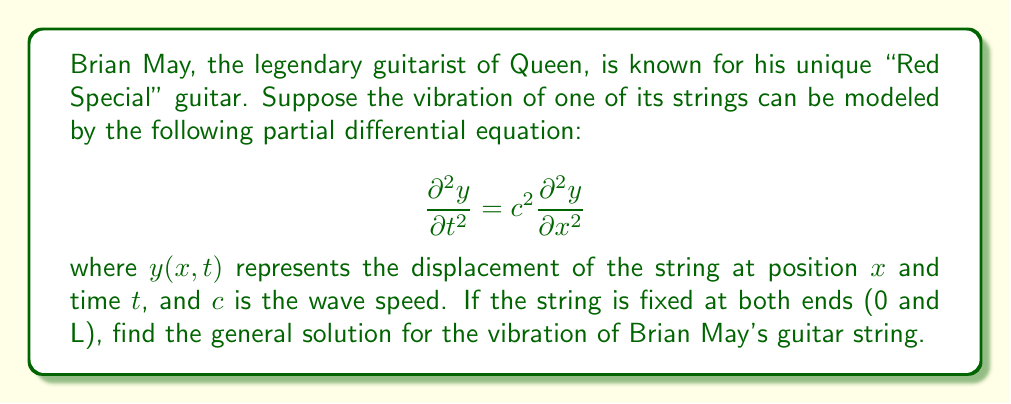Help me with this question. To solve this partial differential equation (PDE) for Brian May's guitar string, we'll follow these steps:

1) First, we need to recognize this as the one-dimensional wave equation. The boundary conditions for a string fixed at both ends are:

   $y(0,t) = y(L,t) = 0$ for all $t$

2) We'll use the method of separation of variables. Let $y(x,t) = X(x)T(t)$

3) Substituting this into the PDE:

   $X(x)T''(t) = c^2X''(x)T(t)$

4) Dividing both sides by $c^2X(x)T(t)$:

   $\frac{T''(t)}{c^2T(t)} = \frac{X''(x)}{X(x)} = -k^2$

   where $-k^2$ is a separation constant (negative to ensure oscillatory solutions).

5) This gives us two ordinary differential equations:

   $T''(t) + c^2k^2T(t) = 0$
   $X''(x) + k^2X(x) = 0$

6) The general solutions are:

   $T(t) = A \cos(ckt) + B \sin(ckt)$
   $X(x) = C \sin(kx) + D \cos(kx)$

7) Applying the boundary conditions:

   $X(0) = 0$ implies $D = 0$
   $X(L) = 0$ implies $\sin(kL) = 0$

8) The latter condition is satisfied when $kL = n\pi$, or $k = \frac{n\pi}{L}$ where $n = 1, 2, 3, ...$

9) Therefore, the general solution is:

   $y_n(x,t) = [A_n \cos(\frac{cn\pi t}{L}) + B_n \sin(\frac{cn\pi t}{L})] \sin(\frac{n\pi x}{L})$

10) The complete solution is the sum of all these modes:

    $y(x,t) = \sum_{n=1}^{\infty} [A_n \cos(\frac{cn\pi t}{L}) + B_n \sin(\frac{cn\pi t}{L})] \sin(\frac{n\pi x}{L})$

where $A_n$ and $B_n$ are determined by the initial conditions.
Answer: $$y(x,t) = \sum_{n=1}^{\infty} [A_n \cos(\frac{cn\pi t}{L}) + B_n \sin(\frac{cn\pi t}{L})] \sin(\frac{n\pi x}{L})$$ 